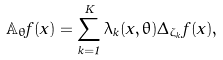<formula> <loc_0><loc_0><loc_500><loc_500>\mathbb { A } _ { \theta } f ( x ) = \sum _ { k = 1 } ^ { K } \lambda _ { k } ( x , \theta ) \Delta _ { \zeta _ { k } } f ( x ) ,</formula> 